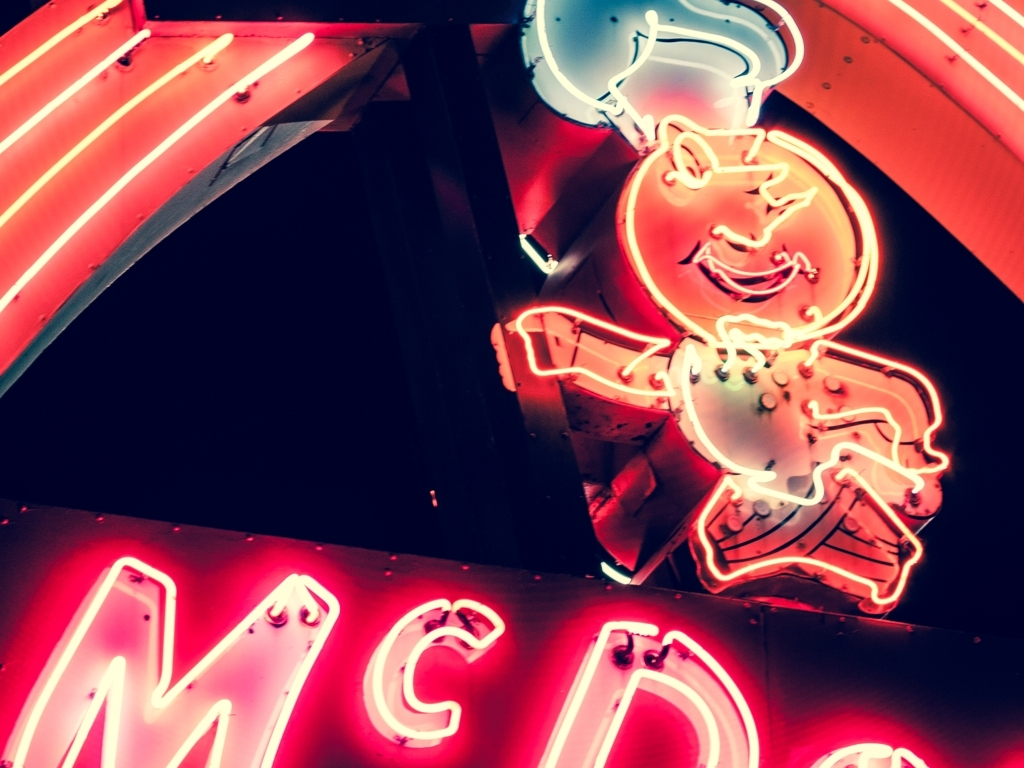Can you tell me what this neon sign is advertising? This neon sign is advertising what appears to be an ice cream product, as indicated by the bright neon depiction of a smiling character holding a large ice cream cone. 